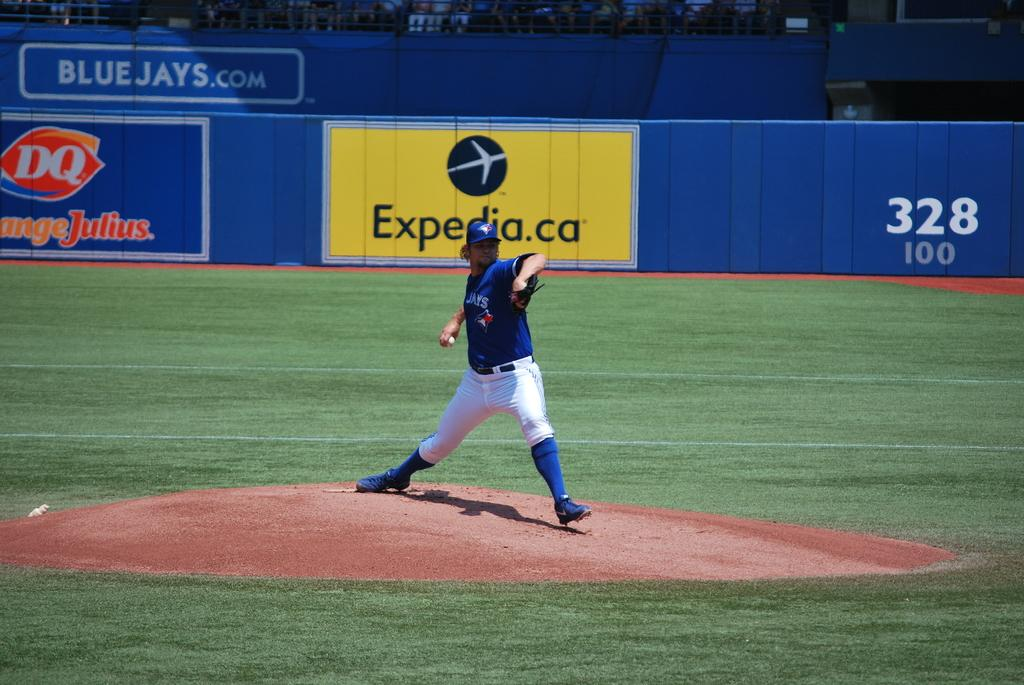Provide a one-sentence caption for the provided image. A Blue Jay's player is pitching the ball on a baseball field. 